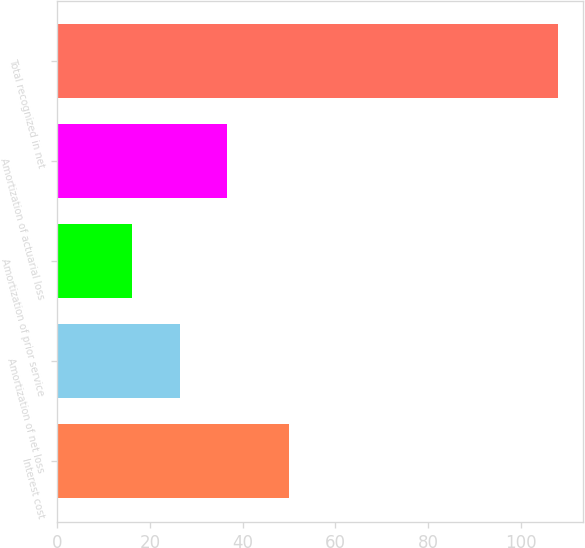Convert chart. <chart><loc_0><loc_0><loc_500><loc_500><bar_chart><fcel>Interest cost<fcel>Amortization of net loss<fcel>Amortization of prior service<fcel>Amortization of actuarial loss<fcel>Total recognized in net<nl><fcel>50<fcel>26.4<fcel>16.2<fcel>36.6<fcel>108<nl></chart> 